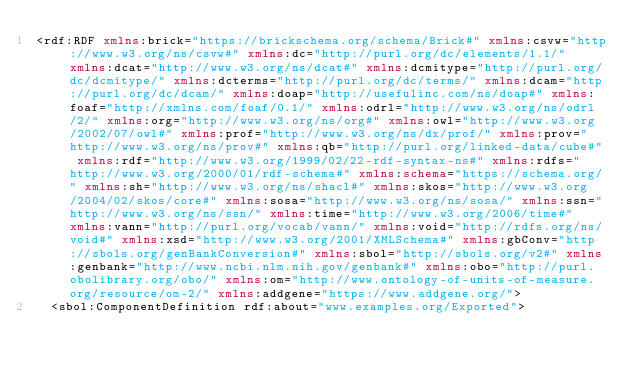<code> <loc_0><loc_0><loc_500><loc_500><_XML_><rdf:RDF xmlns:brick="https://brickschema.org/schema/Brick#" xmlns:csvw="http://www.w3.org/ns/csvw#" xmlns:dc="http://purl.org/dc/elements/1.1/" xmlns:dcat="http://www.w3.org/ns/dcat#" xmlns:dcmitype="http://purl.org/dc/dcmitype/" xmlns:dcterms="http://purl.org/dc/terms/" xmlns:dcam="http://purl.org/dc/dcam/" xmlns:doap="http://usefulinc.com/ns/doap#" xmlns:foaf="http://xmlns.com/foaf/0.1/" xmlns:odrl="http://www.w3.org/ns/odrl/2/" xmlns:org="http://www.w3.org/ns/org#" xmlns:owl="http://www.w3.org/2002/07/owl#" xmlns:prof="http://www.w3.org/ns/dx/prof/" xmlns:prov="http://www.w3.org/ns/prov#" xmlns:qb="http://purl.org/linked-data/cube#" xmlns:rdf="http://www.w3.org/1999/02/22-rdf-syntax-ns#" xmlns:rdfs="http://www.w3.org/2000/01/rdf-schema#" xmlns:schema="https://schema.org/" xmlns:sh="http://www.w3.org/ns/shacl#" xmlns:skos="http://www.w3.org/2004/02/skos/core#" xmlns:sosa="http://www.w3.org/ns/sosa/" xmlns:ssn="http://www.w3.org/ns/ssn/" xmlns:time="http://www.w3.org/2006/time#" xmlns:vann="http://purl.org/vocab/vann/" xmlns:void="http://rdfs.org/ns/void#" xmlns:xsd="http://www.w3.org/2001/XMLSchema#" xmlns:gbConv="http://sbols.org/genBankConversion#" xmlns:sbol="http://sbols.org/v2#" xmlns:genbank="http://www.ncbi.nlm.nih.gov/genbank#" xmlns:obo="http://purl.obolibrary.org/obo/" xmlns:om="http://www.ontology-of-units-of-measure.org/resource/om-2/" xmlns:addgene="https://www.addgene.org/">
  <sbol:ComponentDefinition rdf:about="www.examples.org/Exported"></code> 